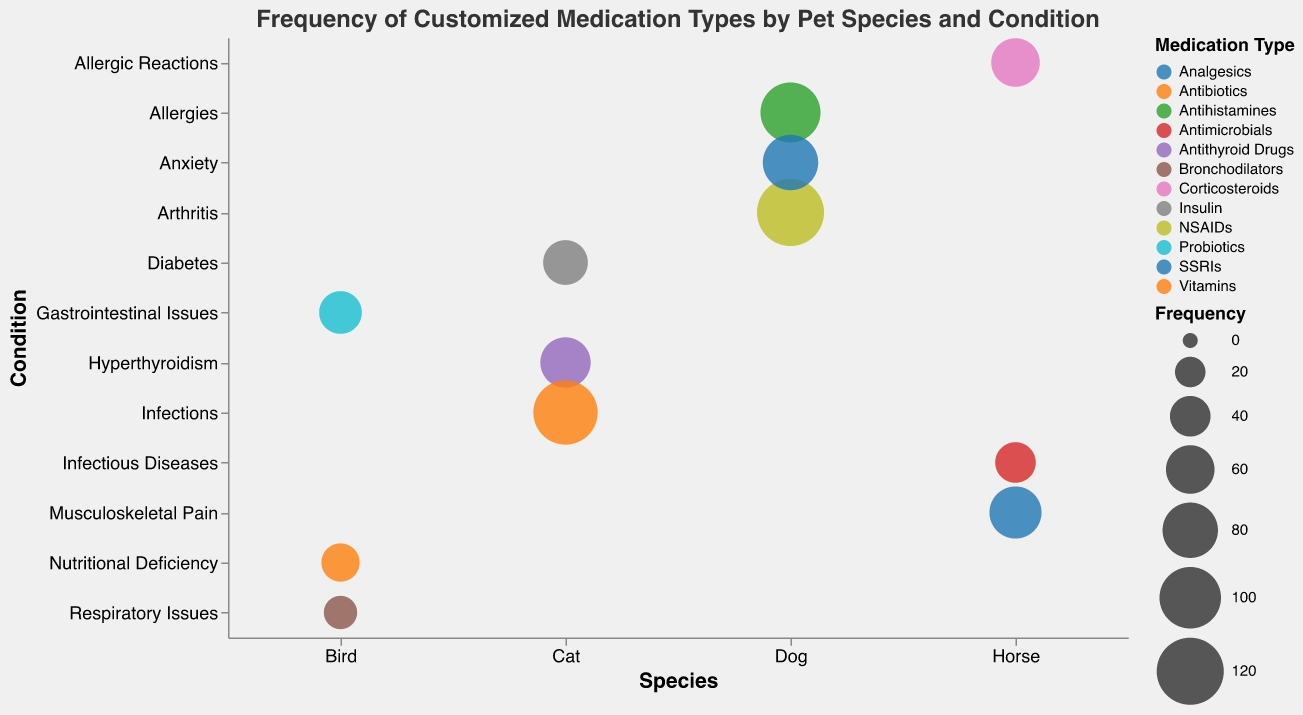What is the title of the bubble chart? The title is displayed on top of the chart and states the main focus of the visualization.
Answer: Frequency of Customized Medication Types by Pet Species and Condition Which pet species has the highest frequency for a single medication type? By looking at the sizes of the bubbles, the largest bubble corresponds to the "Dog" with "120" frequency for "NSAIDs" treating "Arthritis".
Answer: Dog How many different medication types are represented in the chart? Looking at the color legend which maps to different medication types, there are eight distinct medication types listed.
Answer: 8 Which condition in cats has the lowest frequency of medication? Among the bubbles under the "Cat" species, the one with the smallest size represents "Diabetes" treated with "Insulin" having a frequency of "50".
Answer: Diabetes For which condition do birds receive the most customized medications? The largest bubble for "Birds" is for "Gastrointestinal Issues" treated with "Probiotics" having a frequency of "45".
Answer: Gastrointestinal Issues Which condition and medication type combination is treated most frequently across all horses? By examining the largest bubble under the "Horse" species, "Musculoskeletal Pain" treated with "Analgesics" has the highest frequency of "70".
Answer: Musculoskeletal Pain and Analgesics Compare the medication frequency for allergies in dogs and horses. Which one is higher? By comparing the sizes of the bubbles for "Allergies" in "Dogs" and "Allergic Reactions" in "Horses", "Dogs" have a frequency of "95" with "Antihistamines" while "Horses" have a frequency of "60" with "Corticosteroids". So, dogs have a higher frequency.
Answer: Dogs Summarize the total frequency of customized medications for cats. Sum up the frequencies of all the bubbles under the "Cat" species. The frequencies are 65 (Hyperthyroidism) + 50 (Diabetes) + 110 (Infections), which equals 225.
Answer: 225 Which species has the most diverse conditions being treated? By counting the number of unique conditions under each species, "Birds" have 3 unique conditions (Gastrointestinal Issues, Respiratory Issues, Nutritional Deficiency), the same as other species, so there's no one single species with the most diversity.
Answer: None, all are equal 